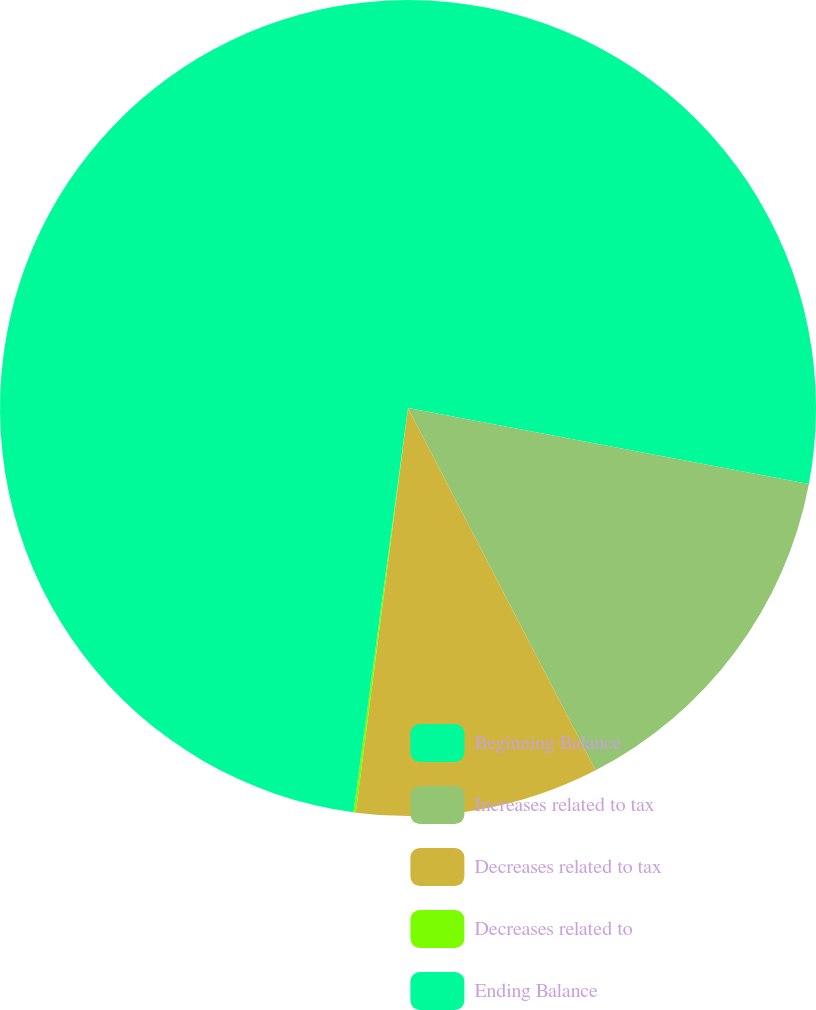<chart> <loc_0><loc_0><loc_500><loc_500><pie_chart><fcel>Beginning Balance<fcel>Increases related to tax<fcel>Decreases related to tax<fcel>Decreases related to<fcel>Ending Balance<nl><fcel>27.98%<fcel>14.42%<fcel>9.65%<fcel>0.09%<fcel>47.87%<nl></chart> 